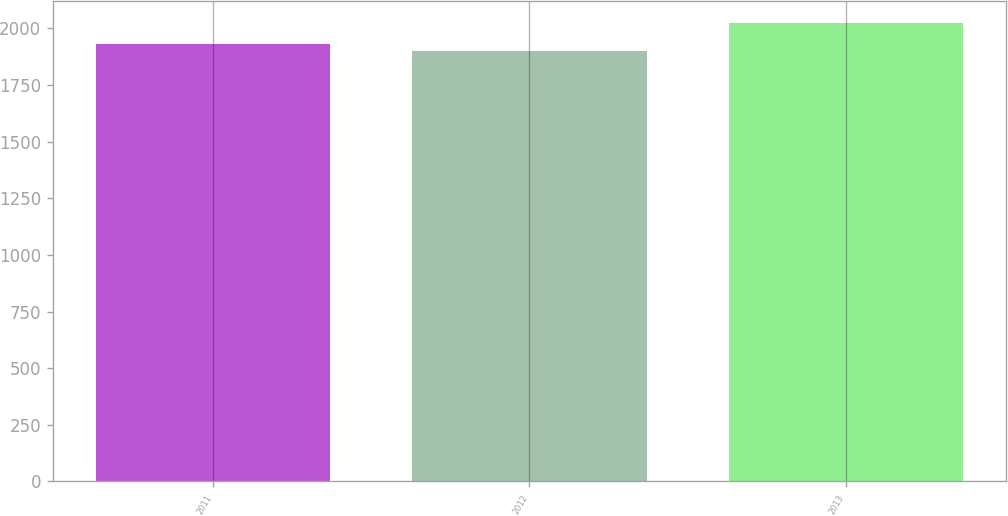<chart> <loc_0><loc_0><loc_500><loc_500><bar_chart><fcel>2011<fcel>2012<fcel>2013<nl><fcel>1933<fcel>1901<fcel>2022<nl></chart> 